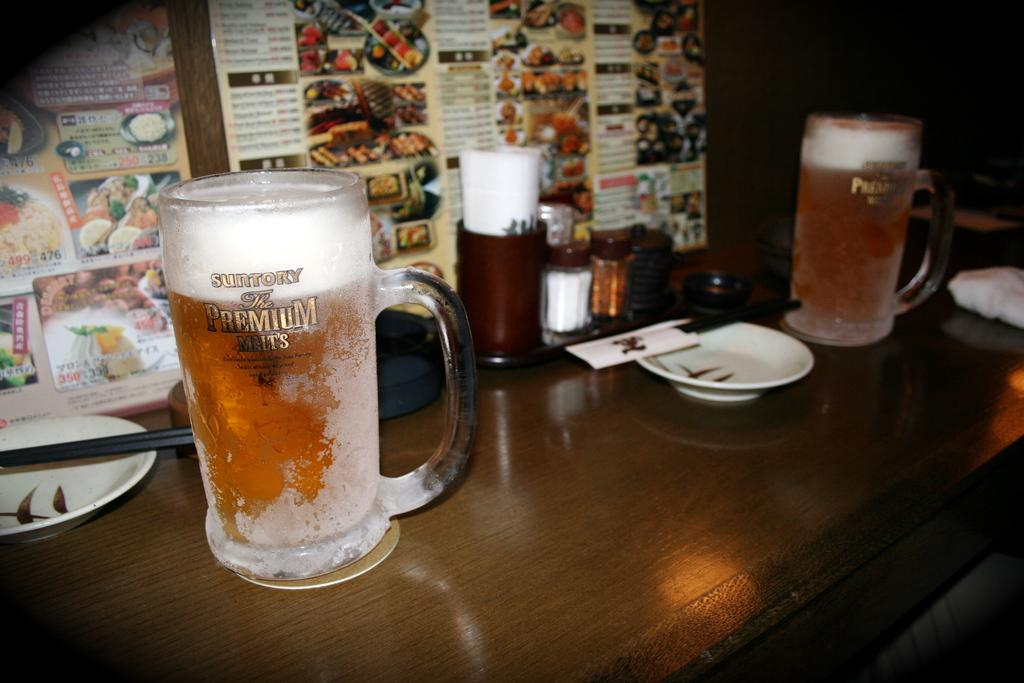<image>
Describe the image concisely. the word premium is on the glass of beer 